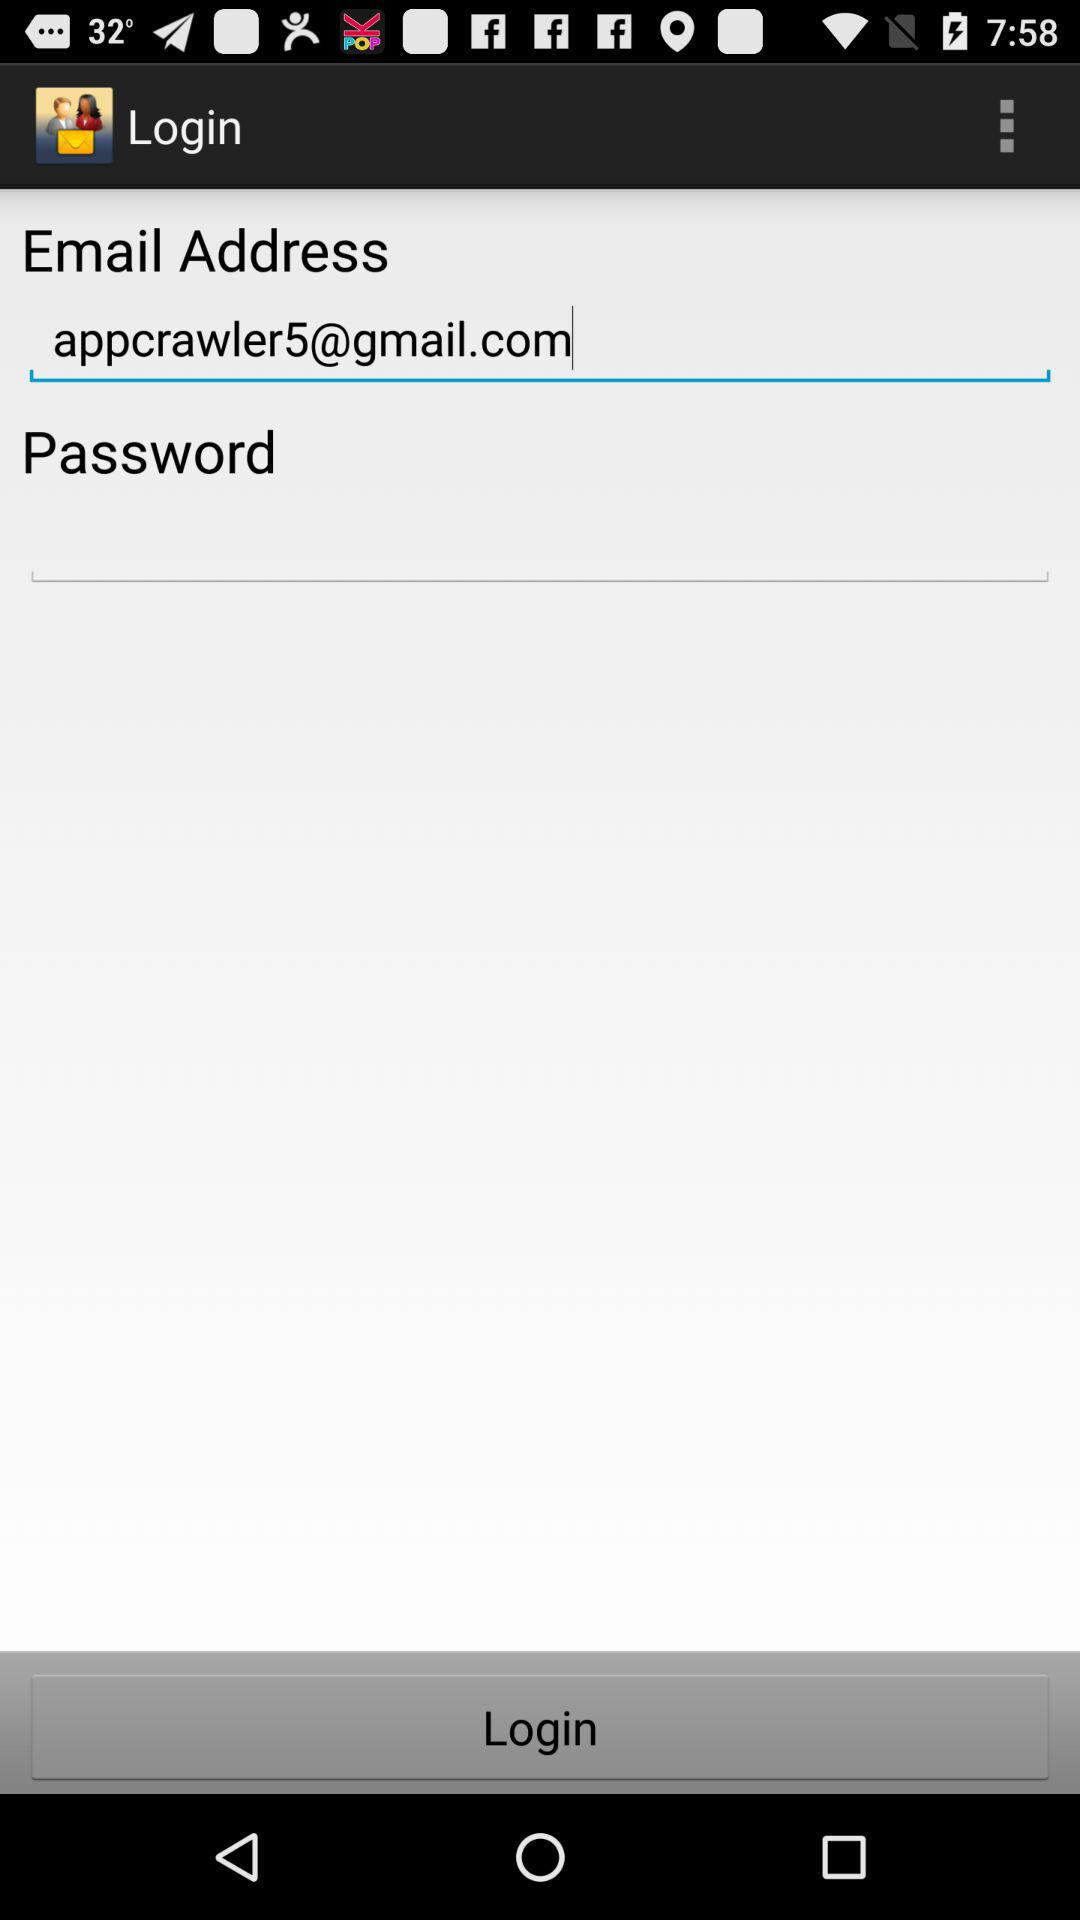How many fields are there in the login form?
Answer the question using a single word or phrase. 2 